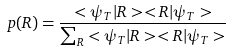<formula> <loc_0><loc_0><loc_500><loc_500>p ( R ) = \frac { < \psi _ { T } | R > < R | \psi _ { T } > } { \sum _ { R } < \psi _ { T } | R > < R | \psi _ { T } > }</formula> 